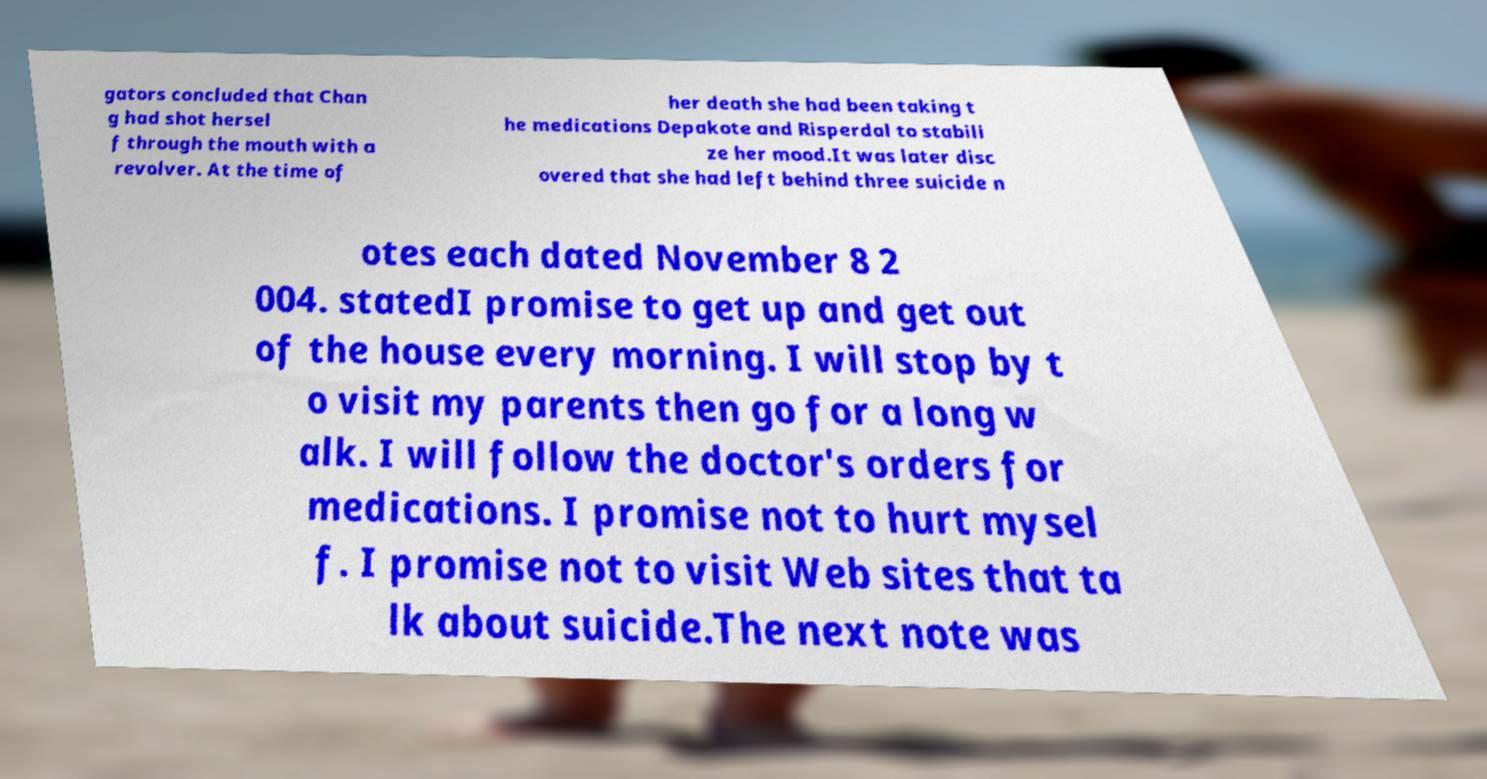Can you read and provide the text displayed in the image?This photo seems to have some interesting text. Can you extract and type it out for me? gators concluded that Chan g had shot hersel f through the mouth with a revolver. At the time of her death she had been taking t he medications Depakote and Risperdal to stabili ze her mood.It was later disc overed that she had left behind three suicide n otes each dated November 8 2 004. statedI promise to get up and get out of the house every morning. I will stop by t o visit my parents then go for a long w alk. I will follow the doctor's orders for medications. I promise not to hurt mysel f. I promise not to visit Web sites that ta lk about suicide.The next note was 